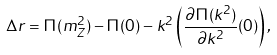<formula> <loc_0><loc_0><loc_500><loc_500>\Delta r = \Pi ( m _ { Z } ^ { 2 } ) - \Pi ( 0 ) - k ^ { 2 } \left ( \frac { \partial \Pi ( k ^ { 2 } ) } { \partial k ^ { 2 } } ( 0 ) \right ) ,</formula> 